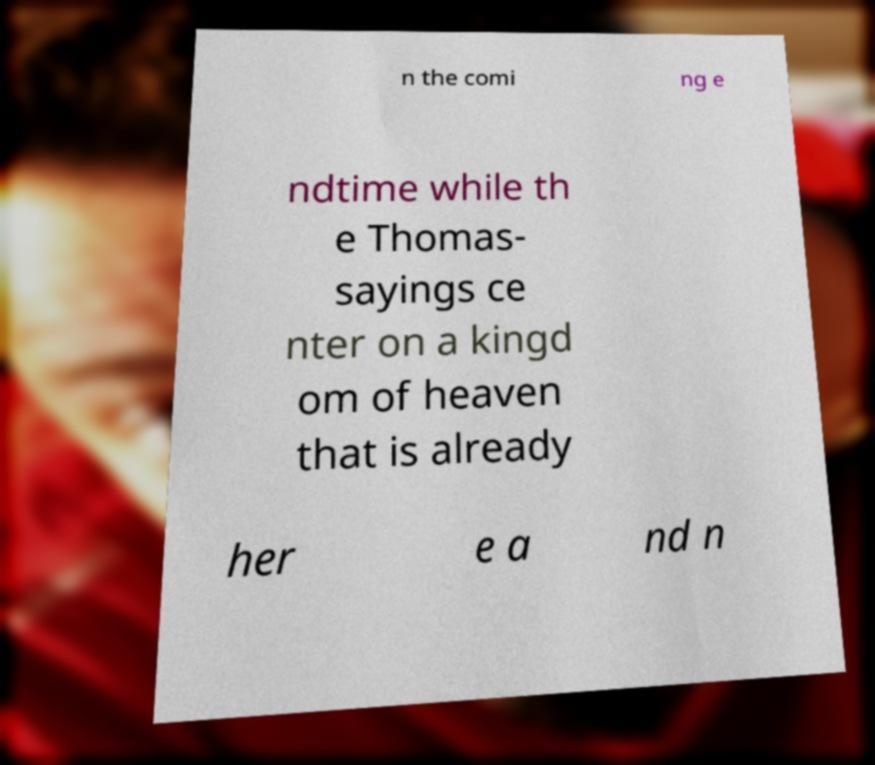Could you assist in decoding the text presented in this image and type it out clearly? n the comi ng e ndtime while th e Thomas- sayings ce nter on a kingd om of heaven that is already her e a nd n 